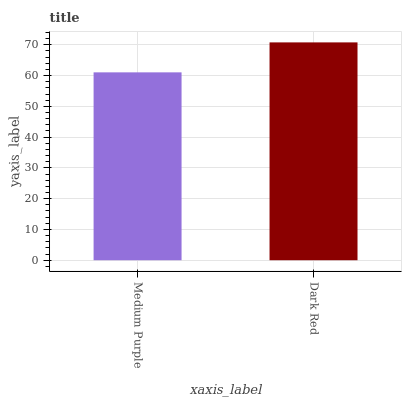Is Medium Purple the minimum?
Answer yes or no. Yes. Is Dark Red the maximum?
Answer yes or no. Yes. Is Dark Red the minimum?
Answer yes or no. No. Is Dark Red greater than Medium Purple?
Answer yes or no. Yes. Is Medium Purple less than Dark Red?
Answer yes or no. Yes. Is Medium Purple greater than Dark Red?
Answer yes or no. No. Is Dark Red less than Medium Purple?
Answer yes or no. No. Is Dark Red the high median?
Answer yes or no. Yes. Is Medium Purple the low median?
Answer yes or no. Yes. Is Medium Purple the high median?
Answer yes or no. No. Is Dark Red the low median?
Answer yes or no. No. 